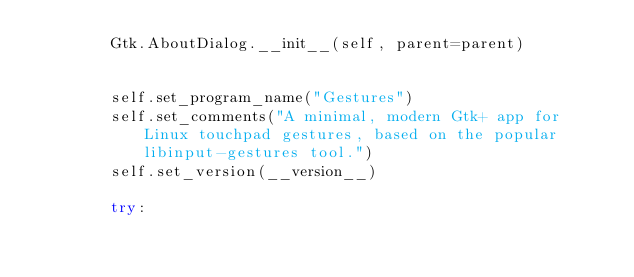<code> <loc_0><loc_0><loc_500><loc_500><_Python_>        Gtk.AboutDialog.__init__(self, parent=parent)

        
        self.set_program_name("Gestures")
        self.set_comments("A minimal, modern Gtk+ app for Linux touchpad gestures, based on the popular libinput-gestures tool.")
        self.set_version(__version__)
        
        try:</code> 